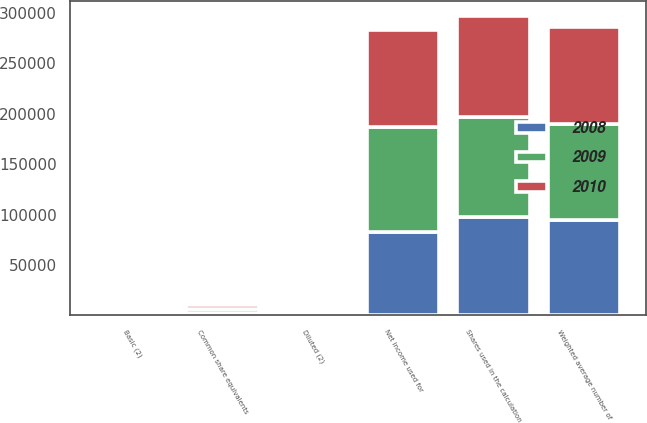Convert chart to OTSL. <chart><loc_0><loc_0><loc_500><loc_500><stacked_bar_chart><ecel><fcel>Net income used for<fcel>Weighted average number of<fcel>Common share equivalents<fcel>Shares used in the calculation<fcel>Basic (2)<fcel>Diluted (2)<nl><fcel>2010<fcel>96285<fcel>95747<fcel>4087<fcel>99834<fcel>1.01<fcel>0.96<nl><fcel>2008<fcel>82964<fcel>94658<fcel>2891<fcel>97549<fcel>0.88<fcel>0.85<nl><fcel>2009<fcel>103871<fcel>95246<fcel>3782<fcel>99028<fcel>1.09<fcel>1.05<nl></chart> 